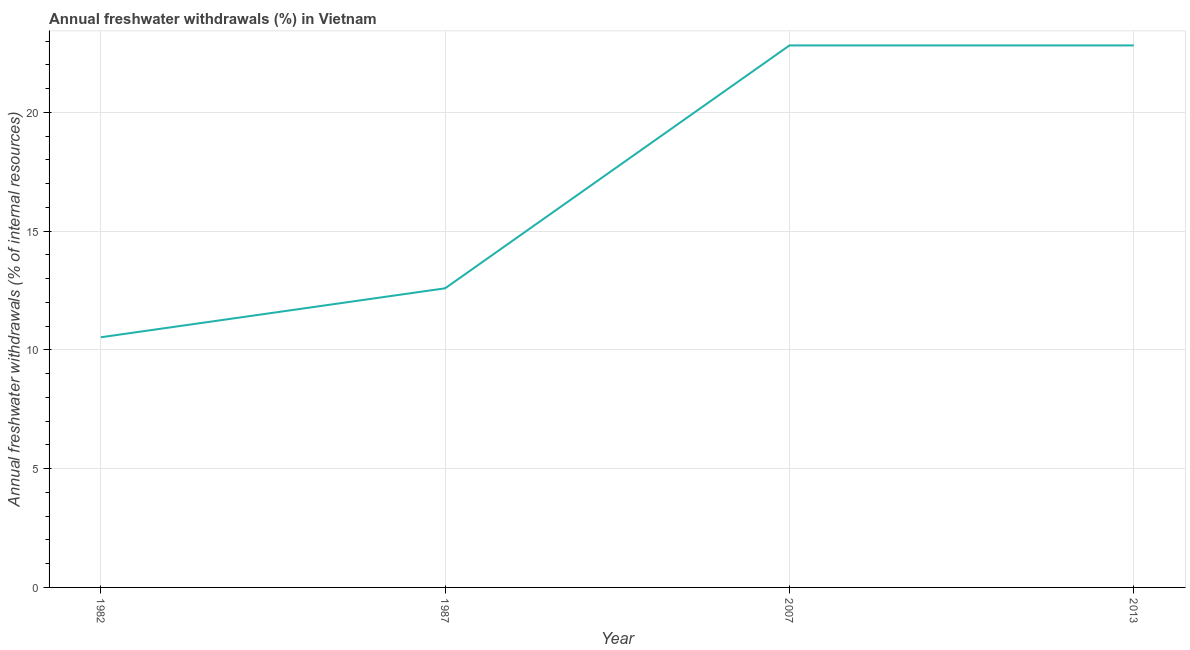What is the annual freshwater withdrawals in 2013?
Ensure brevity in your answer.  22.82. Across all years, what is the maximum annual freshwater withdrawals?
Your response must be concise. 22.82. Across all years, what is the minimum annual freshwater withdrawals?
Keep it short and to the point. 10.53. In which year was the annual freshwater withdrawals minimum?
Offer a very short reply. 1982. What is the sum of the annual freshwater withdrawals?
Ensure brevity in your answer.  68.78. What is the difference between the annual freshwater withdrawals in 1987 and 2013?
Offer a terse response. -10.23. What is the average annual freshwater withdrawals per year?
Offer a very short reply. 17.19. What is the median annual freshwater withdrawals?
Keep it short and to the point. 17.71. What is the ratio of the annual freshwater withdrawals in 1982 to that in 2007?
Offer a very short reply. 0.46. Is the sum of the annual freshwater withdrawals in 1982 and 2007 greater than the maximum annual freshwater withdrawals across all years?
Give a very brief answer. Yes. What is the difference between the highest and the lowest annual freshwater withdrawals?
Offer a very short reply. 12.29. In how many years, is the annual freshwater withdrawals greater than the average annual freshwater withdrawals taken over all years?
Make the answer very short. 2. Does the annual freshwater withdrawals monotonically increase over the years?
Ensure brevity in your answer.  No. How many lines are there?
Keep it short and to the point. 1. Does the graph contain any zero values?
Keep it short and to the point. No. Does the graph contain grids?
Provide a succinct answer. Yes. What is the title of the graph?
Keep it short and to the point. Annual freshwater withdrawals (%) in Vietnam. What is the label or title of the Y-axis?
Offer a terse response. Annual freshwater withdrawals (% of internal resources). What is the Annual freshwater withdrawals (% of internal resources) of 1982?
Your response must be concise. 10.53. What is the Annual freshwater withdrawals (% of internal resources) in 1987?
Ensure brevity in your answer.  12.6. What is the Annual freshwater withdrawals (% of internal resources) in 2007?
Offer a terse response. 22.82. What is the Annual freshwater withdrawals (% of internal resources) in 2013?
Your answer should be very brief. 22.82. What is the difference between the Annual freshwater withdrawals (% of internal resources) in 1982 and 1987?
Provide a succinct answer. -2.06. What is the difference between the Annual freshwater withdrawals (% of internal resources) in 1982 and 2007?
Provide a succinct answer. -12.29. What is the difference between the Annual freshwater withdrawals (% of internal resources) in 1982 and 2013?
Keep it short and to the point. -12.29. What is the difference between the Annual freshwater withdrawals (% of internal resources) in 1987 and 2007?
Offer a very short reply. -10.23. What is the difference between the Annual freshwater withdrawals (% of internal resources) in 1987 and 2013?
Make the answer very short. -10.23. What is the ratio of the Annual freshwater withdrawals (% of internal resources) in 1982 to that in 1987?
Ensure brevity in your answer.  0.84. What is the ratio of the Annual freshwater withdrawals (% of internal resources) in 1982 to that in 2007?
Make the answer very short. 0.46. What is the ratio of the Annual freshwater withdrawals (% of internal resources) in 1982 to that in 2013?
Your answer should be compact. 0.46. What is the ratio of the Annual freshwater withdrawals (% of internal resources) in 1987 to that in 2007?
Provide a short and direct response. 0.55. What is the ratio of the Annual freshwater withdrawals (% of internal resources) in 1987 to that in 2013?
Provide a succinct answer. 0.55. 